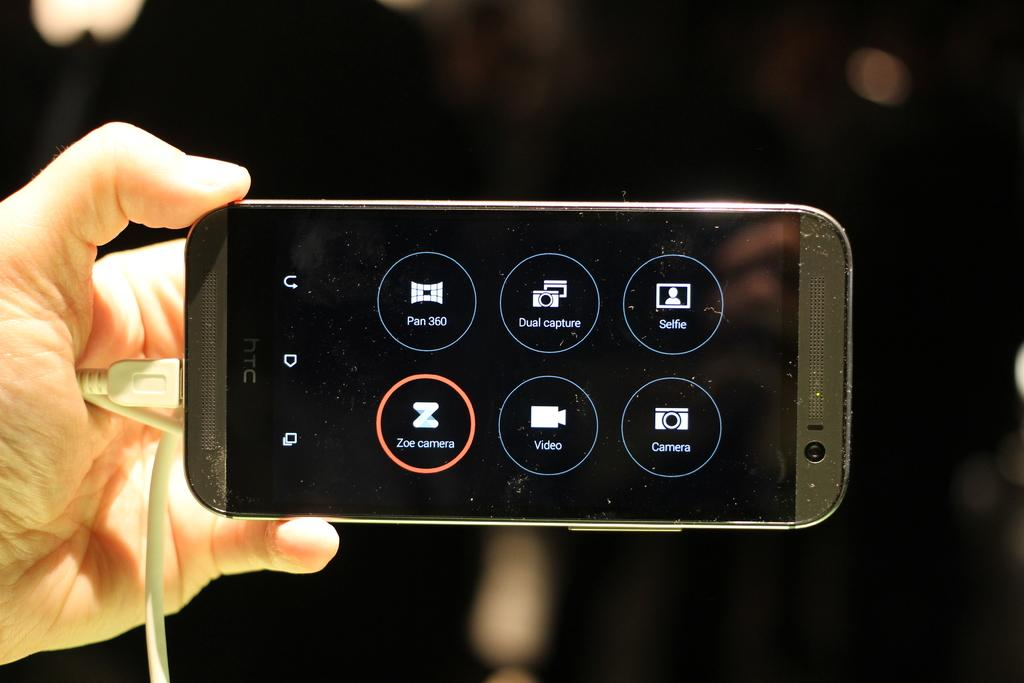What part of the human body is visible in the image? There is a human hand in the image. What is the hand holding? The hand is holding a mobile. How does the hand generate heat in the image? The hand does not generate heat in the image; it is simply holding a mobile. 